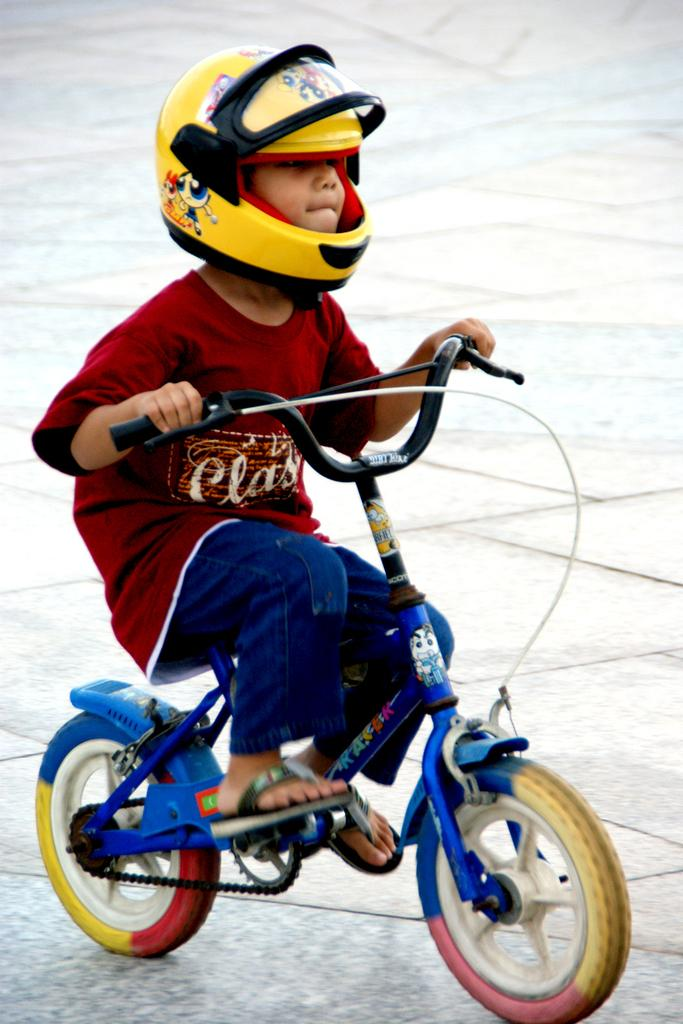Who is the main subject in the image? There is a boy in the image. What is the boy doing in the image? The boy is riding a bicycle. What safety precaution is the boy taking while riding the bicycle? The boy is wearing a helmet. Where is the bicycle located in the image? The bicycle is on the road. What date is circled on the calendar in the image? There is no calendar present in the image. What type of shoes is the queen wearing in the image? There is no queen present in the image. 